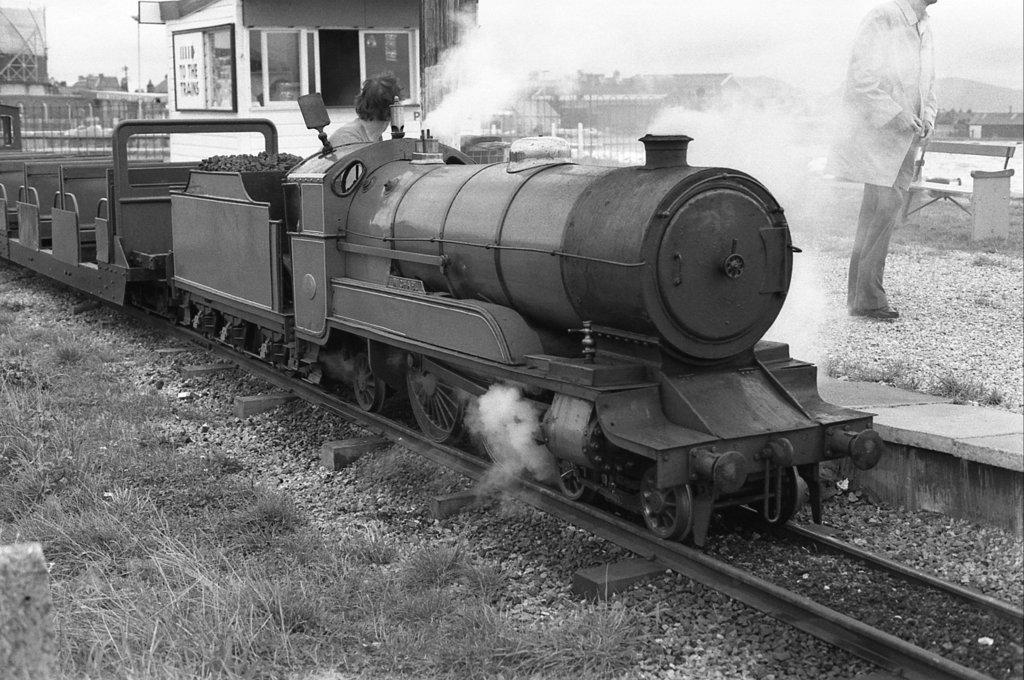<image>
Relay a brief, clear account of the picture shown. A small train is passing a small building with a sign on it that has an arrow pointing in a direction with the words "to the trains" below it. 